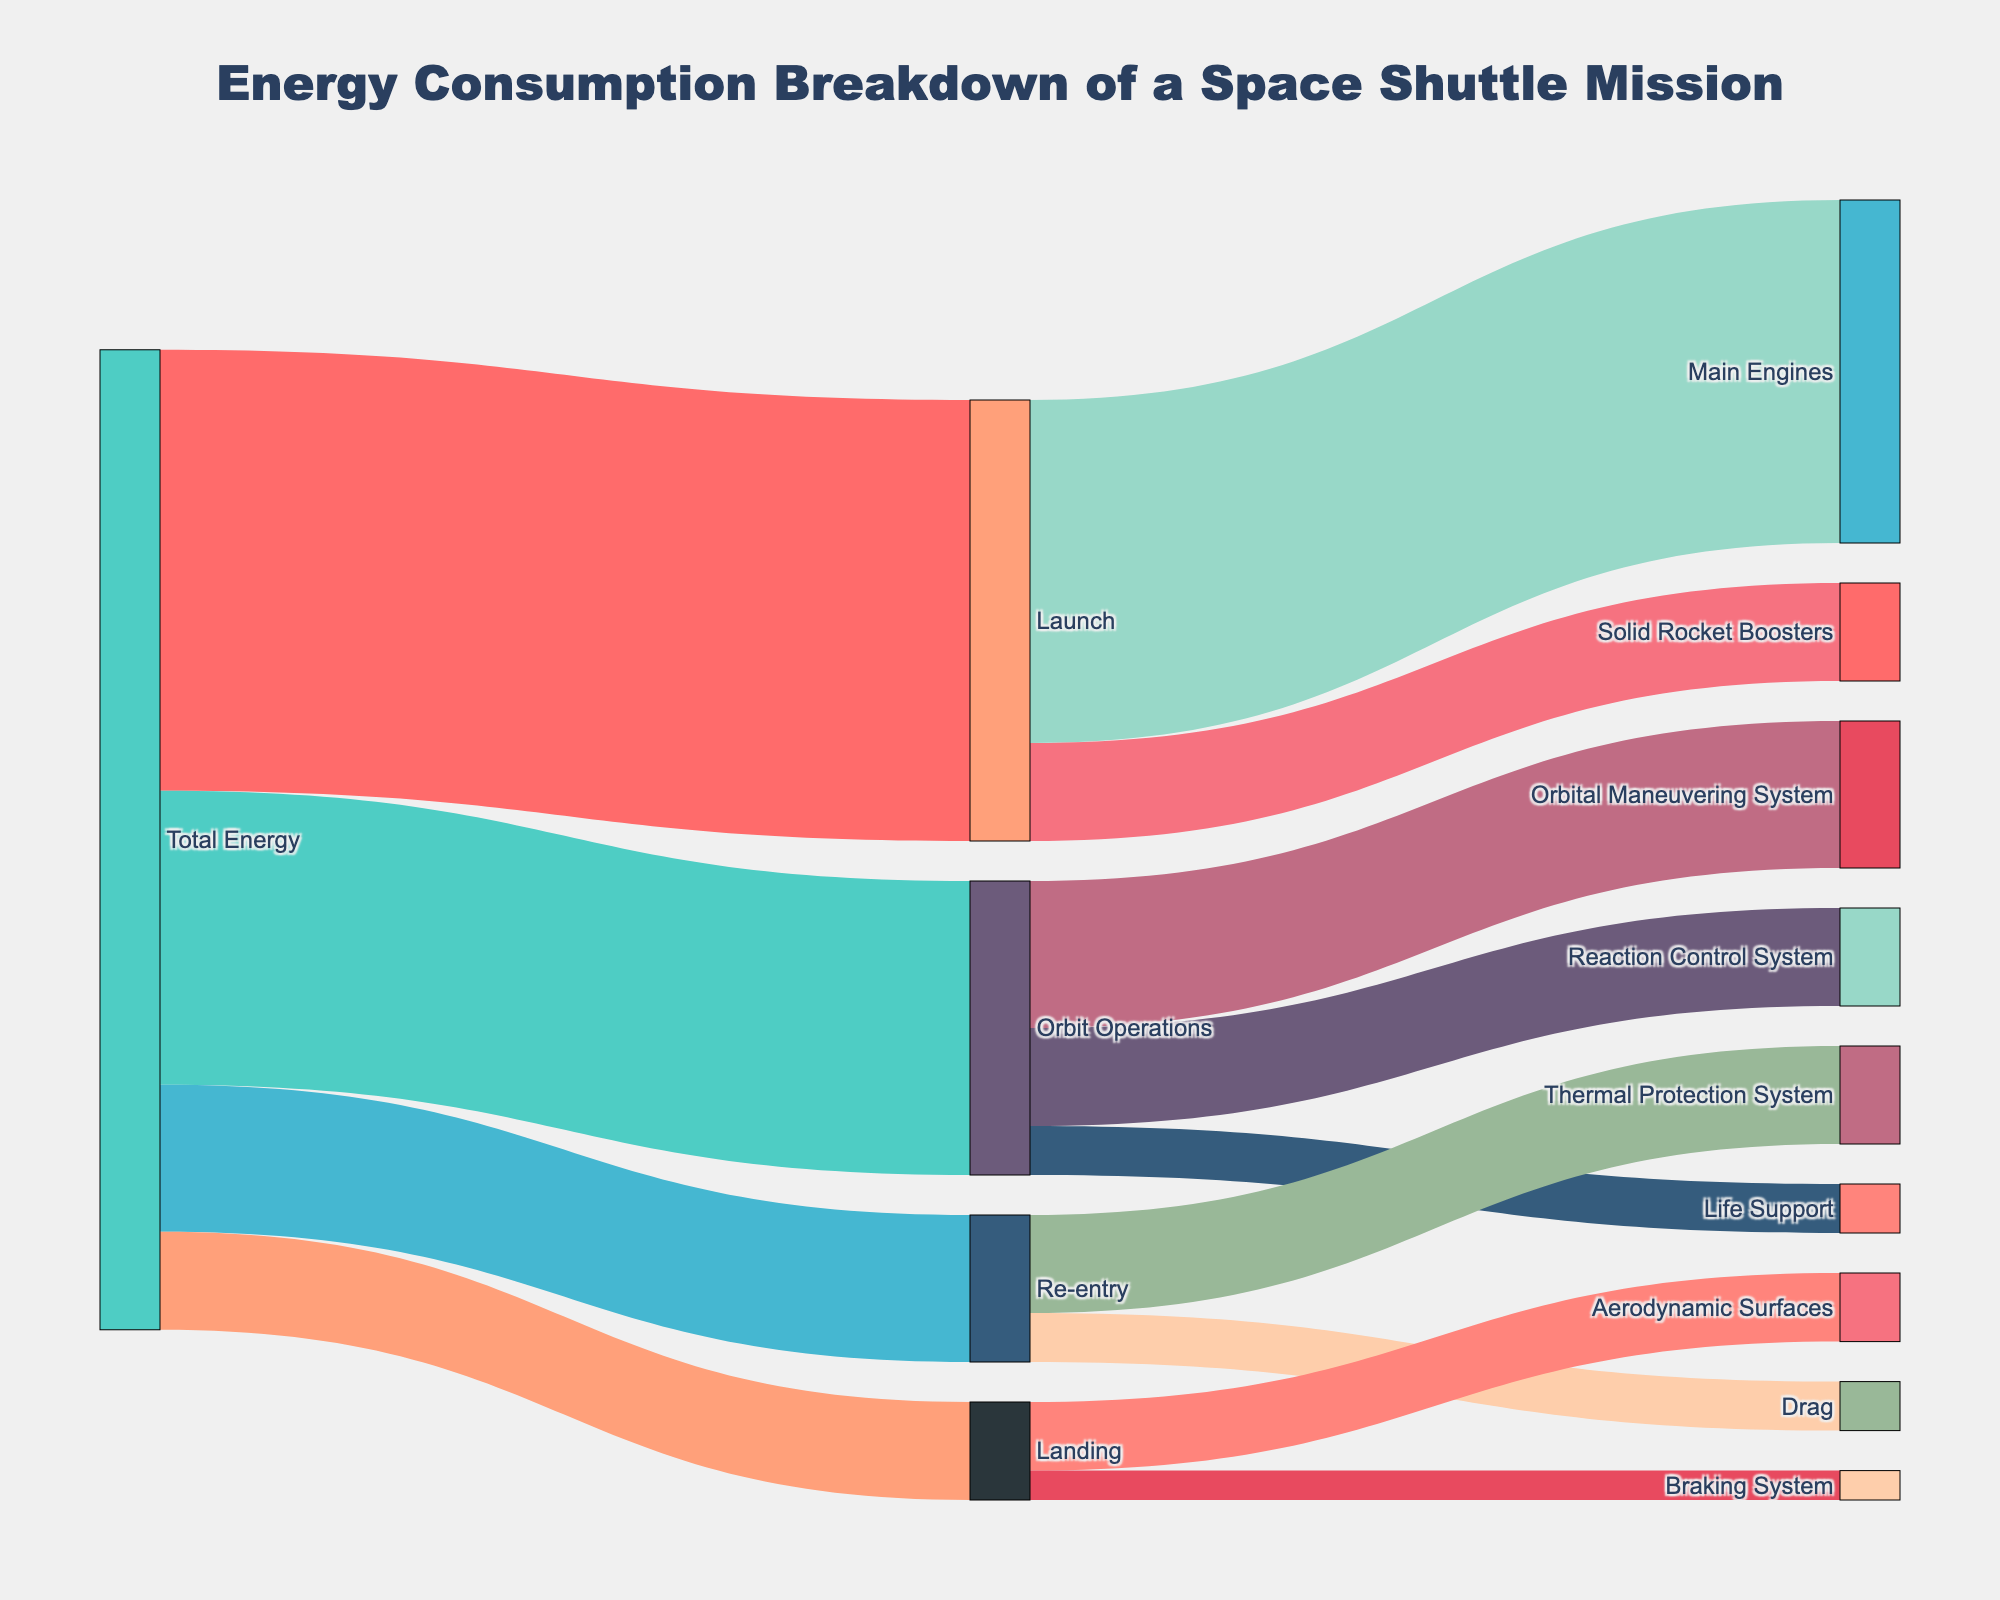what is the title of the figure? The title is usually displayed at the top of the figure. In this case, it is centered at the top of the Sankey Diagram.
Answer: Energy Consumption Breakdown of a Space Shuttle Mission what are the three main stages of the space shuttle mission as shown in the diagram? The three main stages can be identified as the largest nodes directly connected to "Total Energy". They are "Launch", "Orbit Operations", and "Re-entry".
Answer: Launch, Orbit Operations, Re-entry how much energy is allocated to the "Landing" stage? The energy allocated to "Landing" can be found by identifying the value linked from "Total Energy" to "Landing".
Answer: 10000 which component consumes the most energy during the "Launch" stage? Within the "Launch" stage, compare the energy values of "Main Engines" and "Solid Rocket Boosters". The node with the highest value consumes the most energy.
Answer: Main Engines what is the total energy consumed during the "Orbit Operations" stage? Add all the values outgoing from "Orbit Operations". These values are for "Orbital Maneuvering System", "Reaction Control System", and "Life Support".
Answer: 30000 how does the energy consumption of "Thermal Protection System" compare with "Drag" during the "Re-entry" stage? Compare the values connected from "Re-entry" to "Thermal Protection System" and "Drag".
Answer: Thermal Protection System consumes more energy than Drag what is the combined energy consumption of "Aerodynamic Surfaces" and "Braking System" during the "Landing" stage? Add the values of "Aerodynamic Surfaces" and "Braking System" which are connected from "Landing".
Answer: 10000 which stage has the least energy consumption, and what is that value? Compare the values of energy consumption linked directly from "Total Energy" to each stage. The stage with the smallest value is the one with the least energy consumption.
Answer: Landing, 10000 how much more energy does the "Main Engines" consume compared to the "Solid Rocket Boosters" in the "Launch" stage? Subtract the energy value of "Solid Rocket Boosters" from that of "Main Engines".
Answer: 25000 what percentages of the "Total Energy" are used in the "Launch" and "Re-entry" stages? Calculate the percentages by using (segment value / total energy) * 100. For "Launch", it's (45000/100000)*100, and for "Re-entry", it's (15000/100000)*100.
Answer: Launch: 45%, Re-entry: 15% 